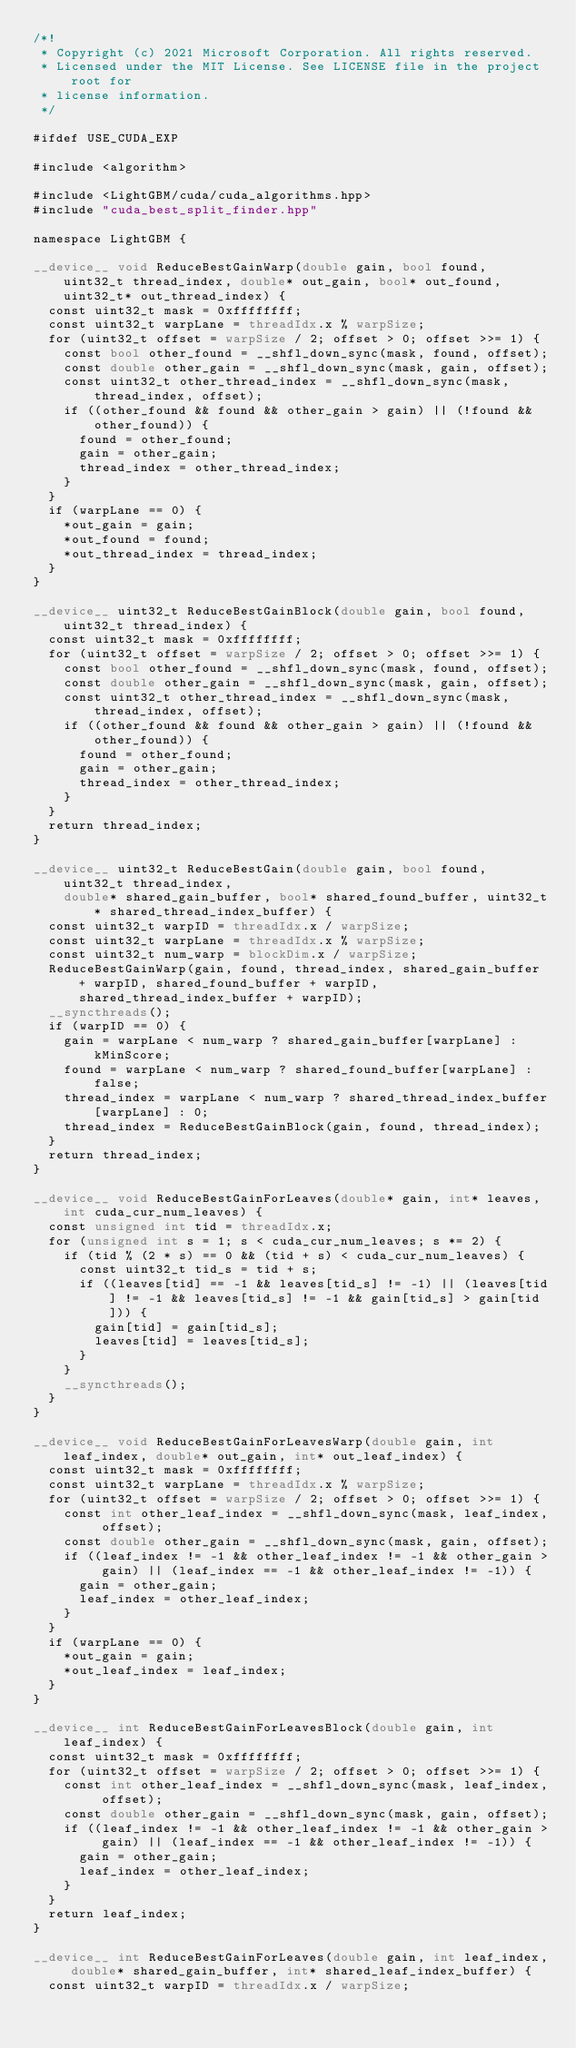Convert code to text. <code><loc_0><loc_0><loc_500><loc_500><_Cuda_>/*!
 * Copyright (c) 2021 Microsoft Corporation. All rights reserved.
 * Licensed under the MIT License. See LICENSE file in the project root for
 * license information.
 */

#ifdef USE_CUDA_EXP

#include <algorithm>

#include <LightGBM/cuda/cuda_algorithms.hpp>
#include "cuda_best_split_finder.hpp"

namespace LightGBM {

__device__ void ReduceBestGainWarp(double gain, bool found, uint32_t thread_index, double* out_gain, bool* out_found, uint32_t* out_thread_index) {
  const uint32_t mask = 0xffffffff;
  const uint32_t warpLane = threadIdx.x % warpSize;
  for (uint32_t offset = warpSize / 2; offset > 0; offset >>= 1) {
    const bool other_found = __shfl_down_sync(mask, found, offset);
    const double other_gain = __shfl_down_sync(mask, gain, offset);
    const uint32_t other_thread_index = __shfl_down_sync(mask, thread_index, offset);
    if ((other_found && found && other_gain > gain) || (!found && other_found)) {
      found = other_found;
      gain = other_gain;
      thread_index = other_thread_index;
    }
  }
  if (warpLane == 0) {
    *out_gain = gain;
    *out_found = found;
    *out_thread_index = thread_index;
  }
}

__device__ uint32_t ReduceBestGainBlock(double gain, bool found, uint32_t thread_index) {
  const uint32_t mask = 0xffffffff;
  for (uint32_t offset = warpSize / 2; offset > 0; offset >>= 1) {
    const bool other_found = __shfl_down_sync(mask, found, offset);
    const double other_gain = __shfl_down_sync(mask, gain, offset);
    const uint32_t other_thread_index = __shfl_down_sync(mask, thread_index, offset);
    if ((other_found && found && other_gain > gain) || (!found && other_found)) {
      found = other_found;
      gain = other_gain;
      thread_index = other_thread_index;
    }
  }
  return thread_index;
}

__device__ uint32_t ReduceBestGain(double gain, bool found, uint32_t thread_index,
    double* shared_gain_buffer, bool* shared_found_buffer, uint32_t* shared_thread_index_buffer) {
  const uint32_t warpID = threadIdx.x / warpSize;
  const uint32_t warpLane = threadIdx.x % warpSize;
  const uint32_t num_warp = blockDim.x / warpSize;
  ReduceBestGainWarp(gain, found, thread_index, shared_gain_buffer + warpID, shared_found_buffer + warpID, shared_thread_index_buffer + warpID);
  __syncthreads();
  if (warpID == 0) {
    gain = warpLane < num_warp ? shared_gain_buffer[warpLane] : kMinScore;
    found = warpLane < num_warp ? shared_found_buffer[warpLane] : false;
    thread_index = warpLane < num_warp ? shared_thread_index_buffer[warpLane] : 0;
    thread_index = ReduceBestGainBlock(gain, found, thread_index);
  }
  return thread_index;
}

__device__ void ReduceBestGainForLeaves(double* gain, int* leaves, int cuda_cur_num_leaves) {
  const unsigned int tid = threadIdx.x;
  for (unsigned int s = 1; s < cuda_cur_num_leaves; s *= 2) {
    if (tid % (2 * s) == 0 && (tid + s) < cuda_cur_num_leaves) {
      const uint32_t tid_s = tid + s;
      if ((leaves[tid] == -1 && leaves[tid_s] != -1) || (leaves[tid] != -1 && leaves[tid_s] != -1 && gain[tid_s] > gain[tid])) {
        gain[tid] = gain[tid_s];
        leaves[tid] = leaves[tid_s];
      }
    }
    __syncthreads();
  }
}

__device__ void ReduceBestGainForLeavesWarp(double gain, int leaf_index, double* out_gain, int* out_leaf_index) {
  const uint32_t mask = 0xffffffff;
  const uint32_t warpLane = threadIdx.x % warpSize;
  for (uint32_t offset = warpSize / 2; offset > 0; offset >>= 1) {
    const int other_leaf_index = __shfl_down_sync(mask, leaf_index, offset);
    const double other_gain = __shfl_down_sync(mask, gain, offset);
    if ((leaf_index != -1 && other_leaf_index != -1 && other_gain > gain) || (leaf_index == -1 && other_leaf_index != -1)) {
      gain = other_gain;
      leaf_index = other_leaf_index;
    }
  }
  if (warpLane == 0) {
    *out_gain = gain;
    *out_leaf_index = leaf_index;
  }
}

__device__ int ReduceBestGainForLeavesBlock(double gain, int leaf_index) {
  const uint32_t mask = 0xffffffff;
  for (uint32_t offset = warpSize / 2; offset > 0; offset >>= 1) {
    const int other_leaf_index = __shfl_down_sync(mask, leaf_index, offset);
    const double other_gain = __shfl_down_sync(mask, gain, offset);
    if ((leaf_index != -1 && other_leaf_index != -1 && other_gain > gain) || (leaf_index == -1 && other_leaf_index != -1)) {
      gain = other_gain;
      leaf_index = other_leaf_index;
    }
  }
  return leaf_index;
}

__device__ int ReduceBestGainForLeaves(double gain, int leaf_index, double* shared_gain_buffer, int* shared_leaf_index_buffer) {
  const uint32_t warpID = threadIdx.x / warpSize;</code> 